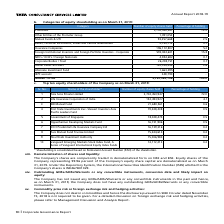According to Tata Consultancy Services's financial document, Who is the majority shareholder?  Tata Sons Private Limited. The document states: "1 Tata Sons Private Limited 2,702,450,947 72.0..." Also, How many equity shares does the Government of Singapore hold in the company? According to the financial document, 18,028,475. The relevant text states: "5 Government of Singapore 18,028,475 0.5..." Also, What percentage shareholding does the majority shareholder have?  According to the financial document, 72 (percentage). The relevant text states: "Promoters 2,702,450,947 72.0..." Also, can you calculate: What is the difference in percentage shareholding between Tata Sons Private Limited and Life Insurance Corporation of India? Based on the calculation: 72-4.1 , the result is 67.9 (percentage). This is based on the information: "Promoters 2,702,450,947 72.0 2 Life Insurance Corporation of India 152,493,927 4.1..." The key data points involved are: 4.1, 72. Also, can you calculate: What is the difference in number of equity shares held between ICICI Prudential Life Insurance and Axis Mutual Fund Trustee? Based on the calculation: 16,139,316-15,244,614 , the result is 894702. This is based on the information: "7 ICICI Prudential Life Insurance Company Ltd 16,139,316 0.4 8 Axis Mutual Fund Trustee Limited 15,244,614 0.4..." The key data points involved are: 15,244,614, 16,139,316. Also, can you calculate: What is the difference between number of equity shares held between Promoters and Insurance Companies? Based on the calculation: 2,702,450,947-196,172,807 , the result is 2506278140. This is based on the information: "Promoters 2,702,450,947 72.0 Insurance Companies 196,172,807 5.2..." The key data points involved are: 196,172,807, 2,702,450,947. 